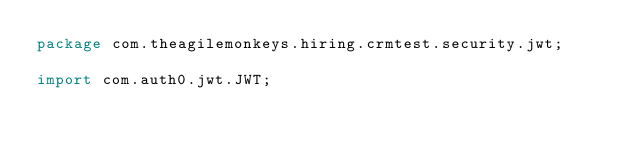Convert code to text. <code><loc_0><loc_0><loc_500><loc_500><_Java_>package com.theagilemonkeys.hiring.crmtest.security.jwt;

import com.auth0.jwt.JWT;</code> 